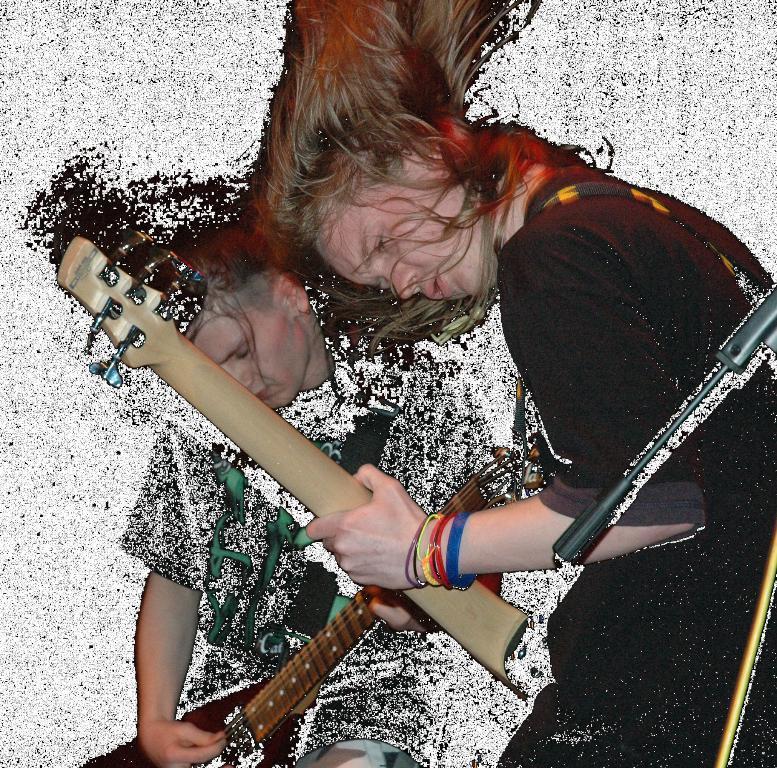In one or two sentences, can you explain what this image depicts? In this image, two peoples are are playing a musical instrument. On right side, we can see a stand. 